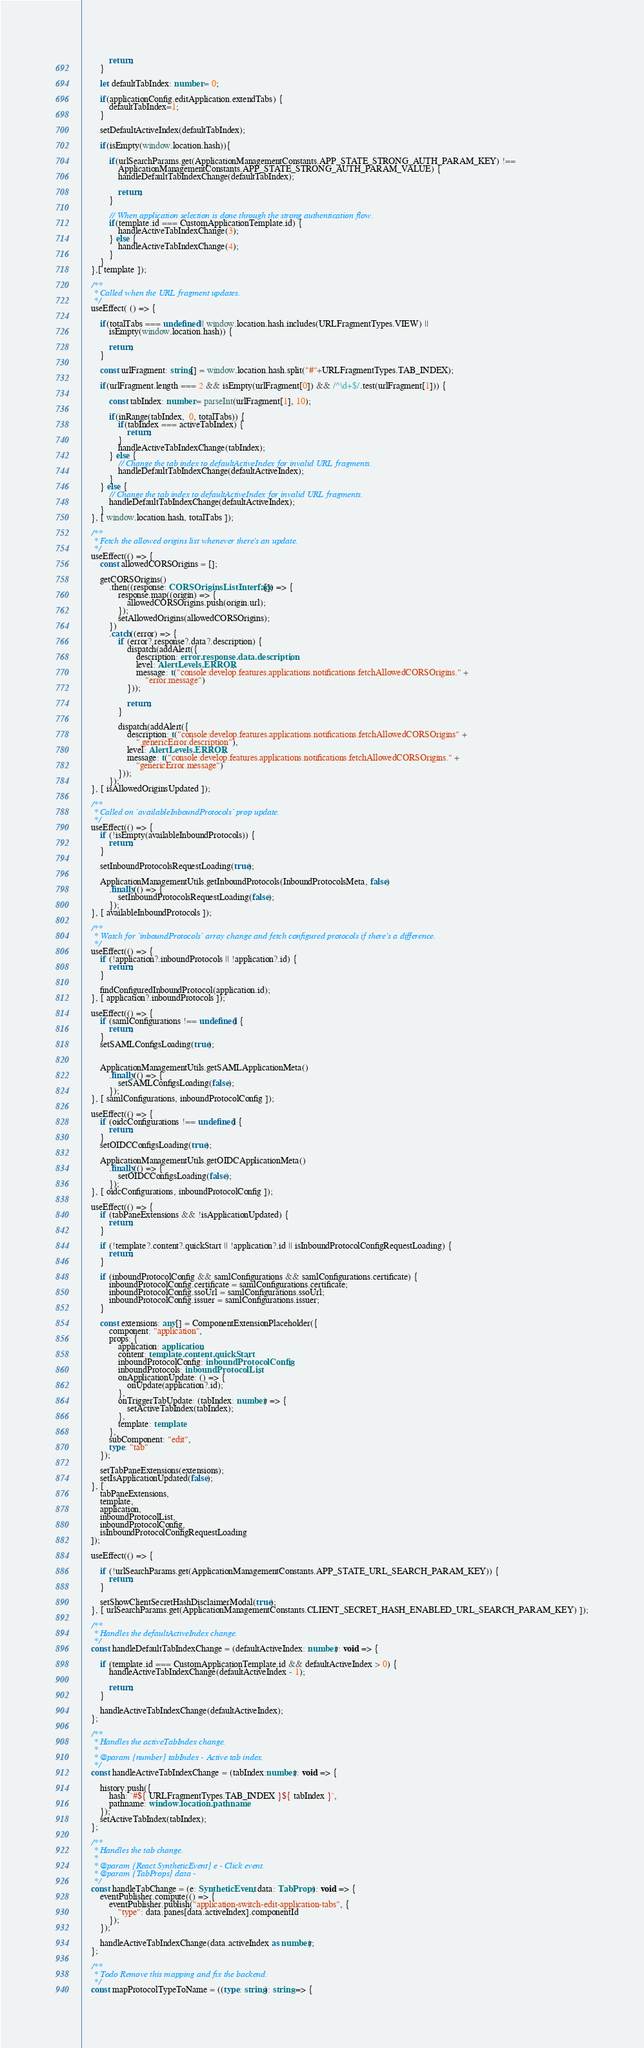Convert code to text. <code><loc_0><loc_0><loc_500><loc_500><_TypeScript_>            return;
        }

        let defaultTabIndex: number = 0;

        if(applicationConfig.editApplication.extendTabs) {
            defaultTabIndex=1;
        }

        setDefaultActiveIndex(defaultTabIndex);

        if(isEmpty(window.location.hash)){

            if(urlSearchParams.get(ApplicationManagementConstants.APP_STATE_STRONG_AUTH_PARAM_KEY) !==
                ApplicationManagementConstants.APP_STATE_STRONG_AUTH_PARAM_VALUE) {
                handleDefaultTabIndexChange(defaultTabIndex);

                return;
            }

            // When application selection is done through the strong authentication flow.
            if(template.id === CustomApplicationTemplate.id) {
                handleActiveTabIndexChange(3);
            } else {
                handleActiveTabIndexChange(4);
            }
        }
    },[ template ]);

    /**
     * Called when the URL fragment updates.
     */
    useEffect( () => {

        if(totalTabs === undefined || window.location.hash.includes(URLFragmentTypes.VIEW) ||
            isEmpty(window.location.hash)) {

            return;
        }

        const urlFragment: string[] = window.location.hash.split("#"+URLFragmentTypes.TAB_INDEX);

        if(urlFragment.length === 2 && isEmpty(urlFragment[0]) && /^\d+$/.test(urlFragment[1])) {

            const tabIndex: number = parseInt(urlFragment[1], 10);

            if(inRange(tabIndex,  0, totalTabs)) {
                if(tabIndex === activeTabIndex) {
                    return;
                }
                handleActiveTabIndexChange(tabIndex);
            } else {
                // Change the tab index to defaultActiveIndex for invalid URL fragments.
                handleDefaultTabIndexChange(defaultActiveIndex);
            }
        } else {
            // Change the tab index to defaultActiveIndex for invalid URL fragments.
            handleDefaultTabIndexChange(defaultActiveIndex);
        }
    }, [ window.location.hash, totalTabs ]);

    /**
     * Fetch the allowed origins list whenever there's an update.
     */
    useEffect(() => {
        const allowedCORSOrigins = [];

        getCORSOrigins()
            .then((response: CORSOriginsListInterface[]) => {
                response.map((origin) => {
                    allowedCORSOrigins.push(origin.url);
                });
                setAllowedOrigins(allowedCORSOrigins);
            })
            .catch((error) => {
                if (error?.response?.data?.description) {
                    dispatch(addAlert({
                        description: error.response.data.description,
                        level: AlertLevels.ERROR,
                        message: t("console:develop.features.applications.notifications.fetchAllowedCORSOrigins." +
                            "error.message")
                    }));

                    return;
                }

                dispatch(addAlert({
                    description: t("console:develop.features.applications.notifications.fetchAllowedCORSOrigins" +
                        ".genericError.description"),
                    level: AlertLevels.ERROR,
                    message: t("console:develop.features.applications.notifications.fetchAllowedCORSOrigins." +
                        "genericError.message")
                }));
            });
    }, [ isAllowedOriginsUpdated ]);

    /**
     * Called on `availableInboundProtocols` prop update.
     */
    useEffect(() => {
        if (!isEmpty(availableInboundProtocols)) {
            return;
        }

        setInboundProtocolsRequestLoading(true);

        ApplicationManagementUtils.getInboundProtocols(InboundProtocolsMeta, false)
            .finally(() => {
                setInboundProtocolsRequestLoading(false);
            });
    }, [ availableInboundProtocols ]);

    /**
     * Watch for `inboundProtocols` array change and fetch configured protocols if there's a difference.
     */
    useEffect(() => {
        if (!application?.inboundProtocols || !application?.id) {
            return;
        }

        findConfiguredInboundProtocol(application.id);
    }, [ application?.inboundProtocols ]);

    useEffect(() => {
        if (samlConfigurations !== undefined) {
            return;
        }
        setSAMLConfigsLoading(true);


        ApplicationManagementUtils.getSAMLApplicationMeta()
            .finally(() => {
                setSAMLConfigsLoading(false);
            });
    }, [ samlConfigurations, inboundProtocolConfig ]);

    useEffect(() => {
        if (oidcConfigurations !== undefined) {
            return;
        }
        setOIDCConfigsLoading(true);

        ApplicationManagementUtils.getOIDCApplicationMeta()
            .finally(() => {
                setOIDCConfigsLoading(false);
            });
    }, [ oidcConfigurations, inboundProtocolConfig ]);

    useEffect(() => {
        if (tabPaneExtensions && !isApplicationUpdated) {
            return;
        }

        if (!template?.content?.quickStart || !application?.id || isInboundProtocolConfigRequestLoading) {
            return;
        }

        if (inboundProtocolConfig && samlConfigurations && samlConfigurations.certificate) {
            inboundProtocolConfig.certificate = samlConfigurations.certificate;
            inboundProtocolConfig.ssoUrl = samlConfigurations.ssoUrl;
            inboundProtocolConfig.issuer = samlConfigurations.issuer;
        }

        const extensions: any[] = ComponentExtensionPlaceholder({
            component: "application",
            props: {
                application: application,
                content: template.content.quickStart,
                inboundProtocolConfig: inboundProtocolConfig,
                inboundProtocols: inboundProtocolList,
                onApplicationUpdate: () => {
                    onUpdate(application?.id);
                },
                onTriggerTabUpdate: (tabIndex: number) => {
                    setActiveTabIndex(tabIndex);
                },
                template: template
            },
            subComponent: "edit",
            type: "tab"
        });

        setTabPaneExtensions(extensions);
        setIsApplicationUpdated(false);
    }, [
        tabPaneExtensions,
        template,
        application,
        inboundProtocolList,
        inboundProtocolConfig,
        isInboundProtocolConfigRequestLoading
    ]);

    useEffect(() => {

        if (!urlSearchParams.get(ApplicationManagementConstants.APP_STATE_URL_SEARCH_PARAM_KEY)) {
            return;
        }

        setShowClientSecretHashDisclaimerModal(true);
    }, [ urlSearchParams.get(ApplicationManagementConstants.CLIENT_SECRET_HASH_ENABLED_URL_SEARCH_PARAM_KEY) ]);

    /**
     * Handles the defaultActiveIndex change.
     */
    const handleDefaultTabIndexChange = (defaultActiveIndex: number): void => {

        if (template.id === CustomApplicationTemplate.id && defaultActiveIndex > 0) {
            handleActiveTabIndexChange(defaultActiveIndex - 1);

            return;
        }

        handleActiveTabIndexChange(defaultActiveIndex);
    };

    /**
     * Handles the activeTabIndex change.
     *
     * @param {number} tabIndex - Active tab index.
     */
    const handleActiveTabIndexChange = (tabIndex:number): void => {

        history.push({
            hash: `#${ URLFragmentTypes.TAB_INDEX }${ tabIndex }`,
            pathname: window.location.pathname
        });
        setActiveTabIndex(tabIndex);
    };

    /**
     * Handles the tab change.
     *
     * @param {React.SyntheticEvent} e - Click event.
     * @param {TabProps} data - 
     */
    const handleTabChange = (e: SyntheticEvent, data: TabProps): void => {
        eventPublisher.compute(() => {
            eventPublisher.publish("application-switch-edit-application-tabs", {
                "type": data.panes[data.activeIndex].componentId
            });
        });

        handleActiveTabIndexChange(data.activeIndex as number);
    };

    /**
     * Todo Remove this mapping and fix the backend.
     */
    const mapProtocolTypeToName = ((type: string): string => {</code> 